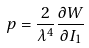<formula> <loc_0><loc_0><loc_500><loc_500>p = \frac { 2 } { \lambda ^ { 4 } } \frac { \partial W } { \partial I _ { 1 } }</formula> 